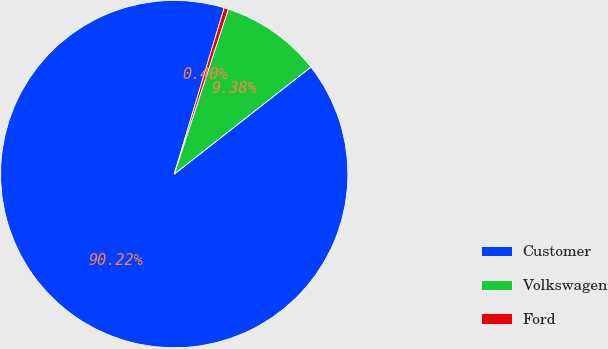Convert chart to OTSL. <chart><loc_0><loc_0><loc_500><loc_500><pie_chart><fcel>Customer<fcel>Volkswagen<fcel>Ford<nl><fcel>90.21%<fcel>9.38%<fcel>0.4%<nl></chart> 